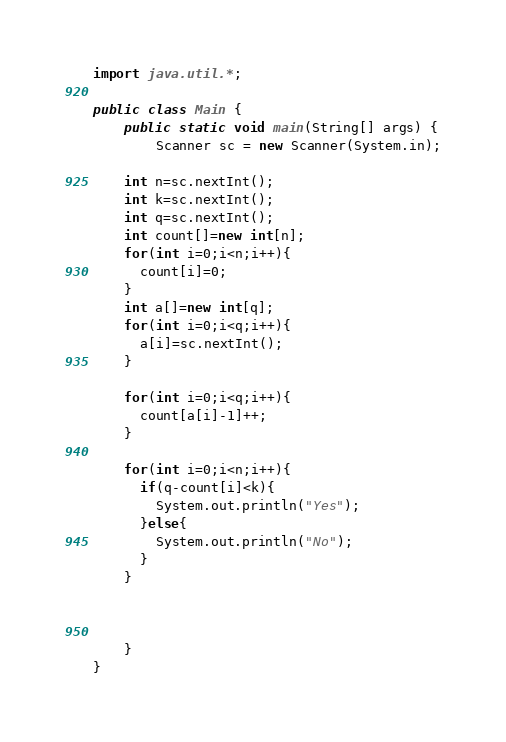<code> <loc_0><loc_0><loc_500><loc_500><_Java_>import java.util.*;

public class Main {
    public static void main(String[] args) {
 		Scanner sc = new Scanner(System.in);

    int n=sc.nextInt();
    int k=sc.nextInt();
    int q=sc.nextInt();
    int count[]=new int[n];
    for(int i=0;i<n;i++){
      count[i]=0;
    }
    int a[]=new int[q];
    for(int i=0;i<q;i++){
      a[i]=sc.nextInt();
    }

    for(int i=0;i<q;i++){
      count[a[i]-1]++;
    }

    for(int i=0;i<n;i++){
      if(q-count[i]<k){
        System.out.println("Yes");
      }else{
        System.out.println("No");
      }
    }



	}
}
</code> 